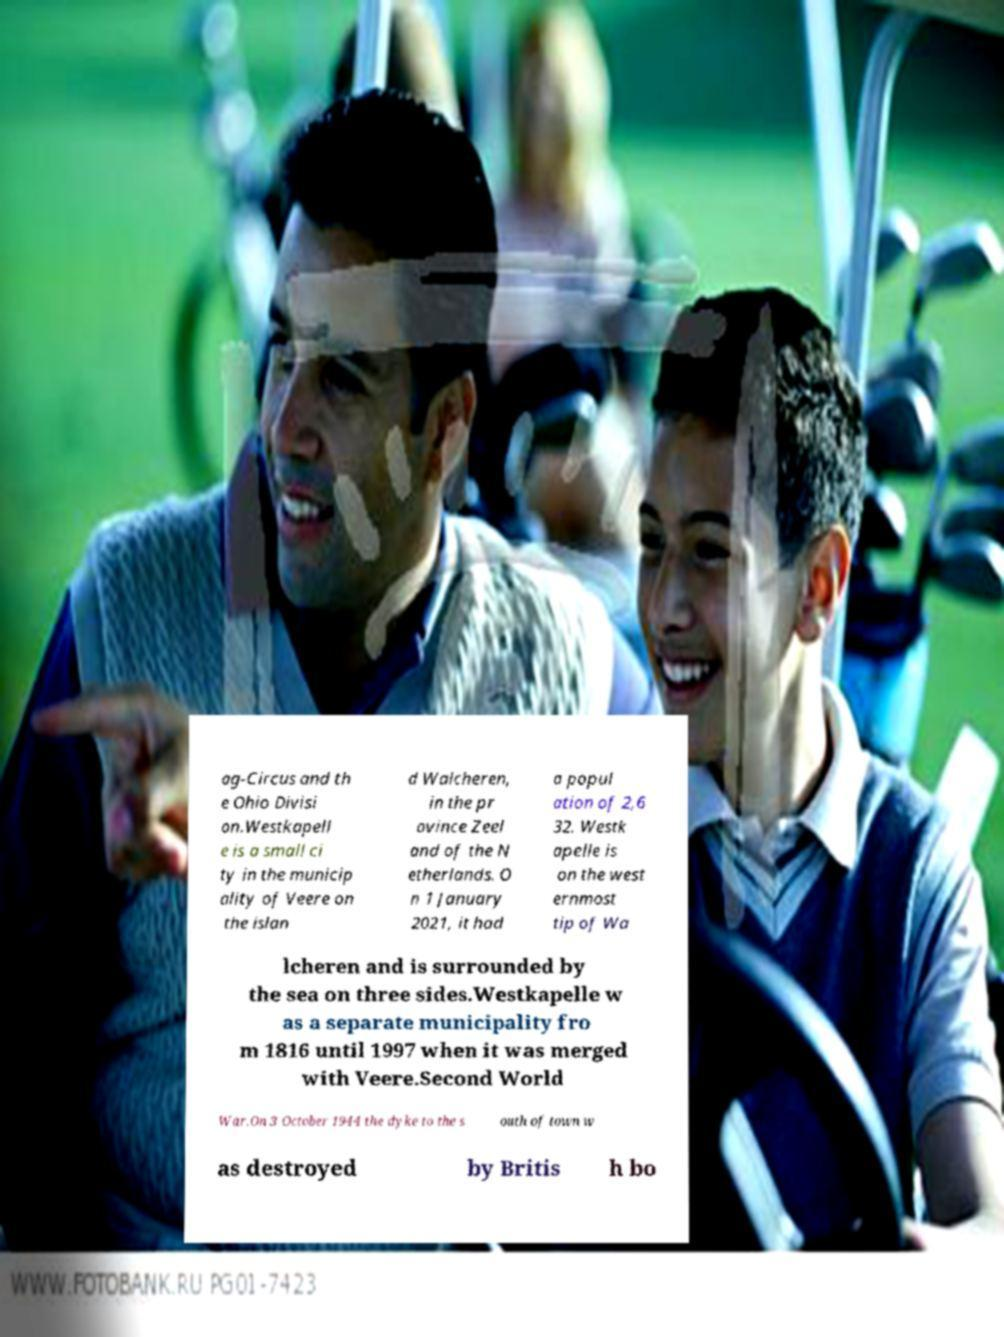For documentation purposes, I need the text within this image transcribed. Could you provide that? ag-Circus and th e Ohio Divisi on.Westkapell e is a small ci ty in the municip ality of Veere on the islan d Walcheren, in the pr ovince Zeel and of the N etherlands. O n 1 January 2021, it had a popul ation of 2,6 32. Westk apelle is on the west ernmost tip of Wa lcheren and is surrounded by the sea on three sides.Westkapelle w as a separate municipality fro m 1816 until 1997 when it was merged with Veere.Second World War.On 3 October 1944 the dyke to the s outh of town w as destroyed by Britis h bo 